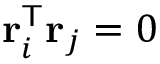Convert formula to latex. <formula><loc_0><loc_0><loc_500><loc_500>r _ { i } ^ { T } r _ { j } = 0</formula> 